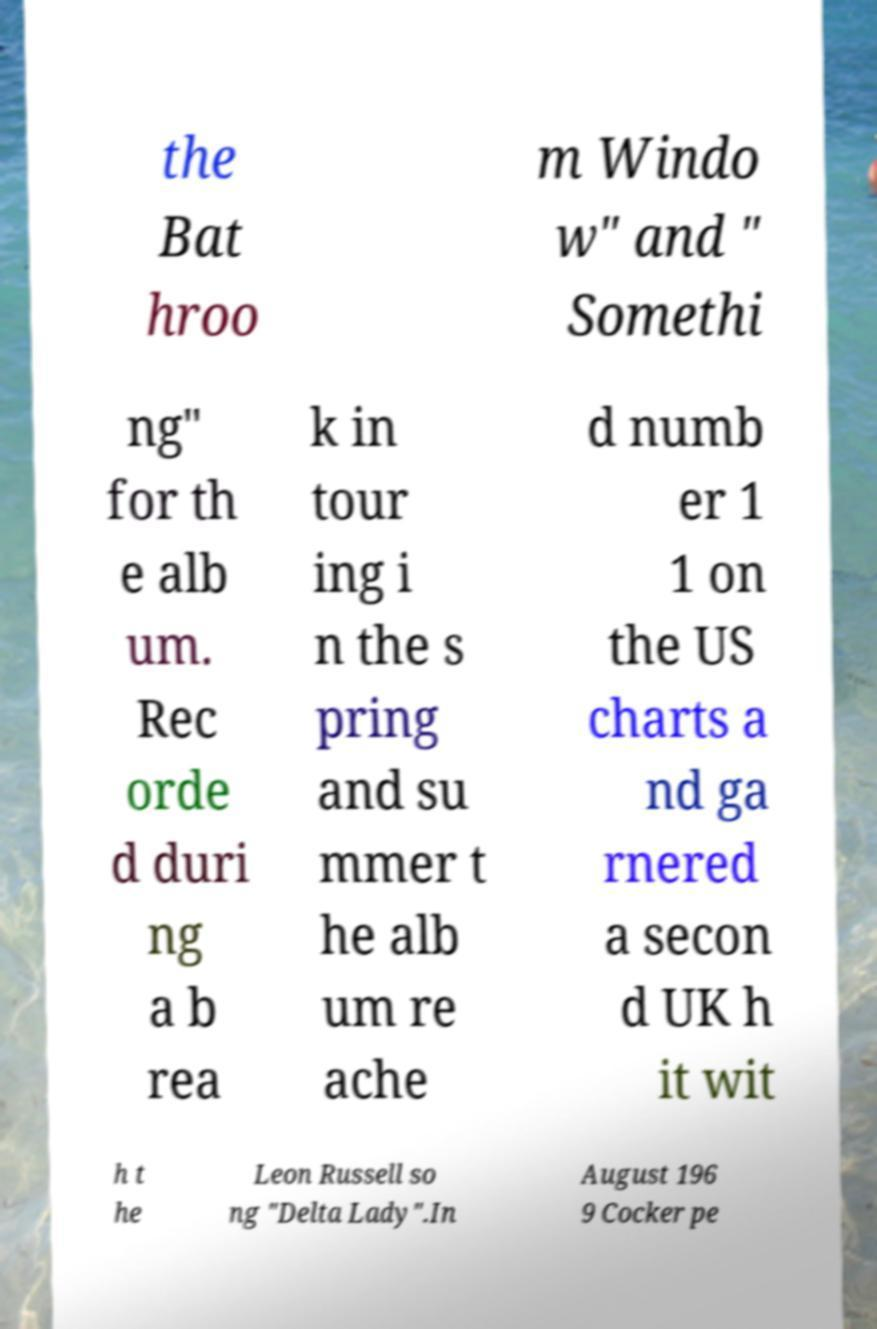There's text embedded in this image that I need extracted. Can you transcribe it verbatim? the Bat hroo m Windo w" and " Somethi ng" for th e alb um. Rec orde d duri ng a b rea k in tour ing i n the s pring and su mmer t he alb um re ache d numb er 1 1 on the US charts a nd ga rnered a secon d UK h it wit h t he Leon Russell so ng "Delta Lady".In August 196 9 Cocker pe 